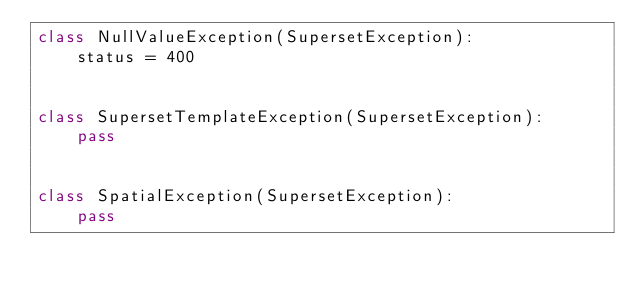<code> <loc_0><loc_0><loc_500><loc_500><_Python_>class NullValueException(SupersetException):
    status = 400


class SupersetTemplateException(SupersetException):
    pass


class SpatialException(SupersetException):
    pass
</code> 